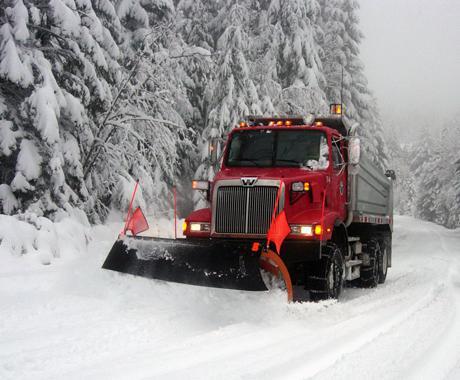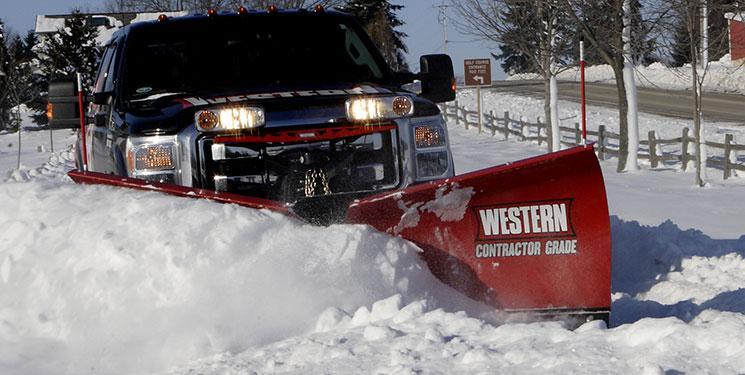The first image is the image on the left, the second image is the image on the right. Considering the images on both sides, is "There are flags on the plow blade in the image on the left." valid? Answer yes or no. Yes. The first image is the image on the left, the second image is the image on the right. Analyze the images presented: Is the assertion "The left image shows exactly one commercial snowplow truck facing the camera." valid? Answer yes or no. Yes. 